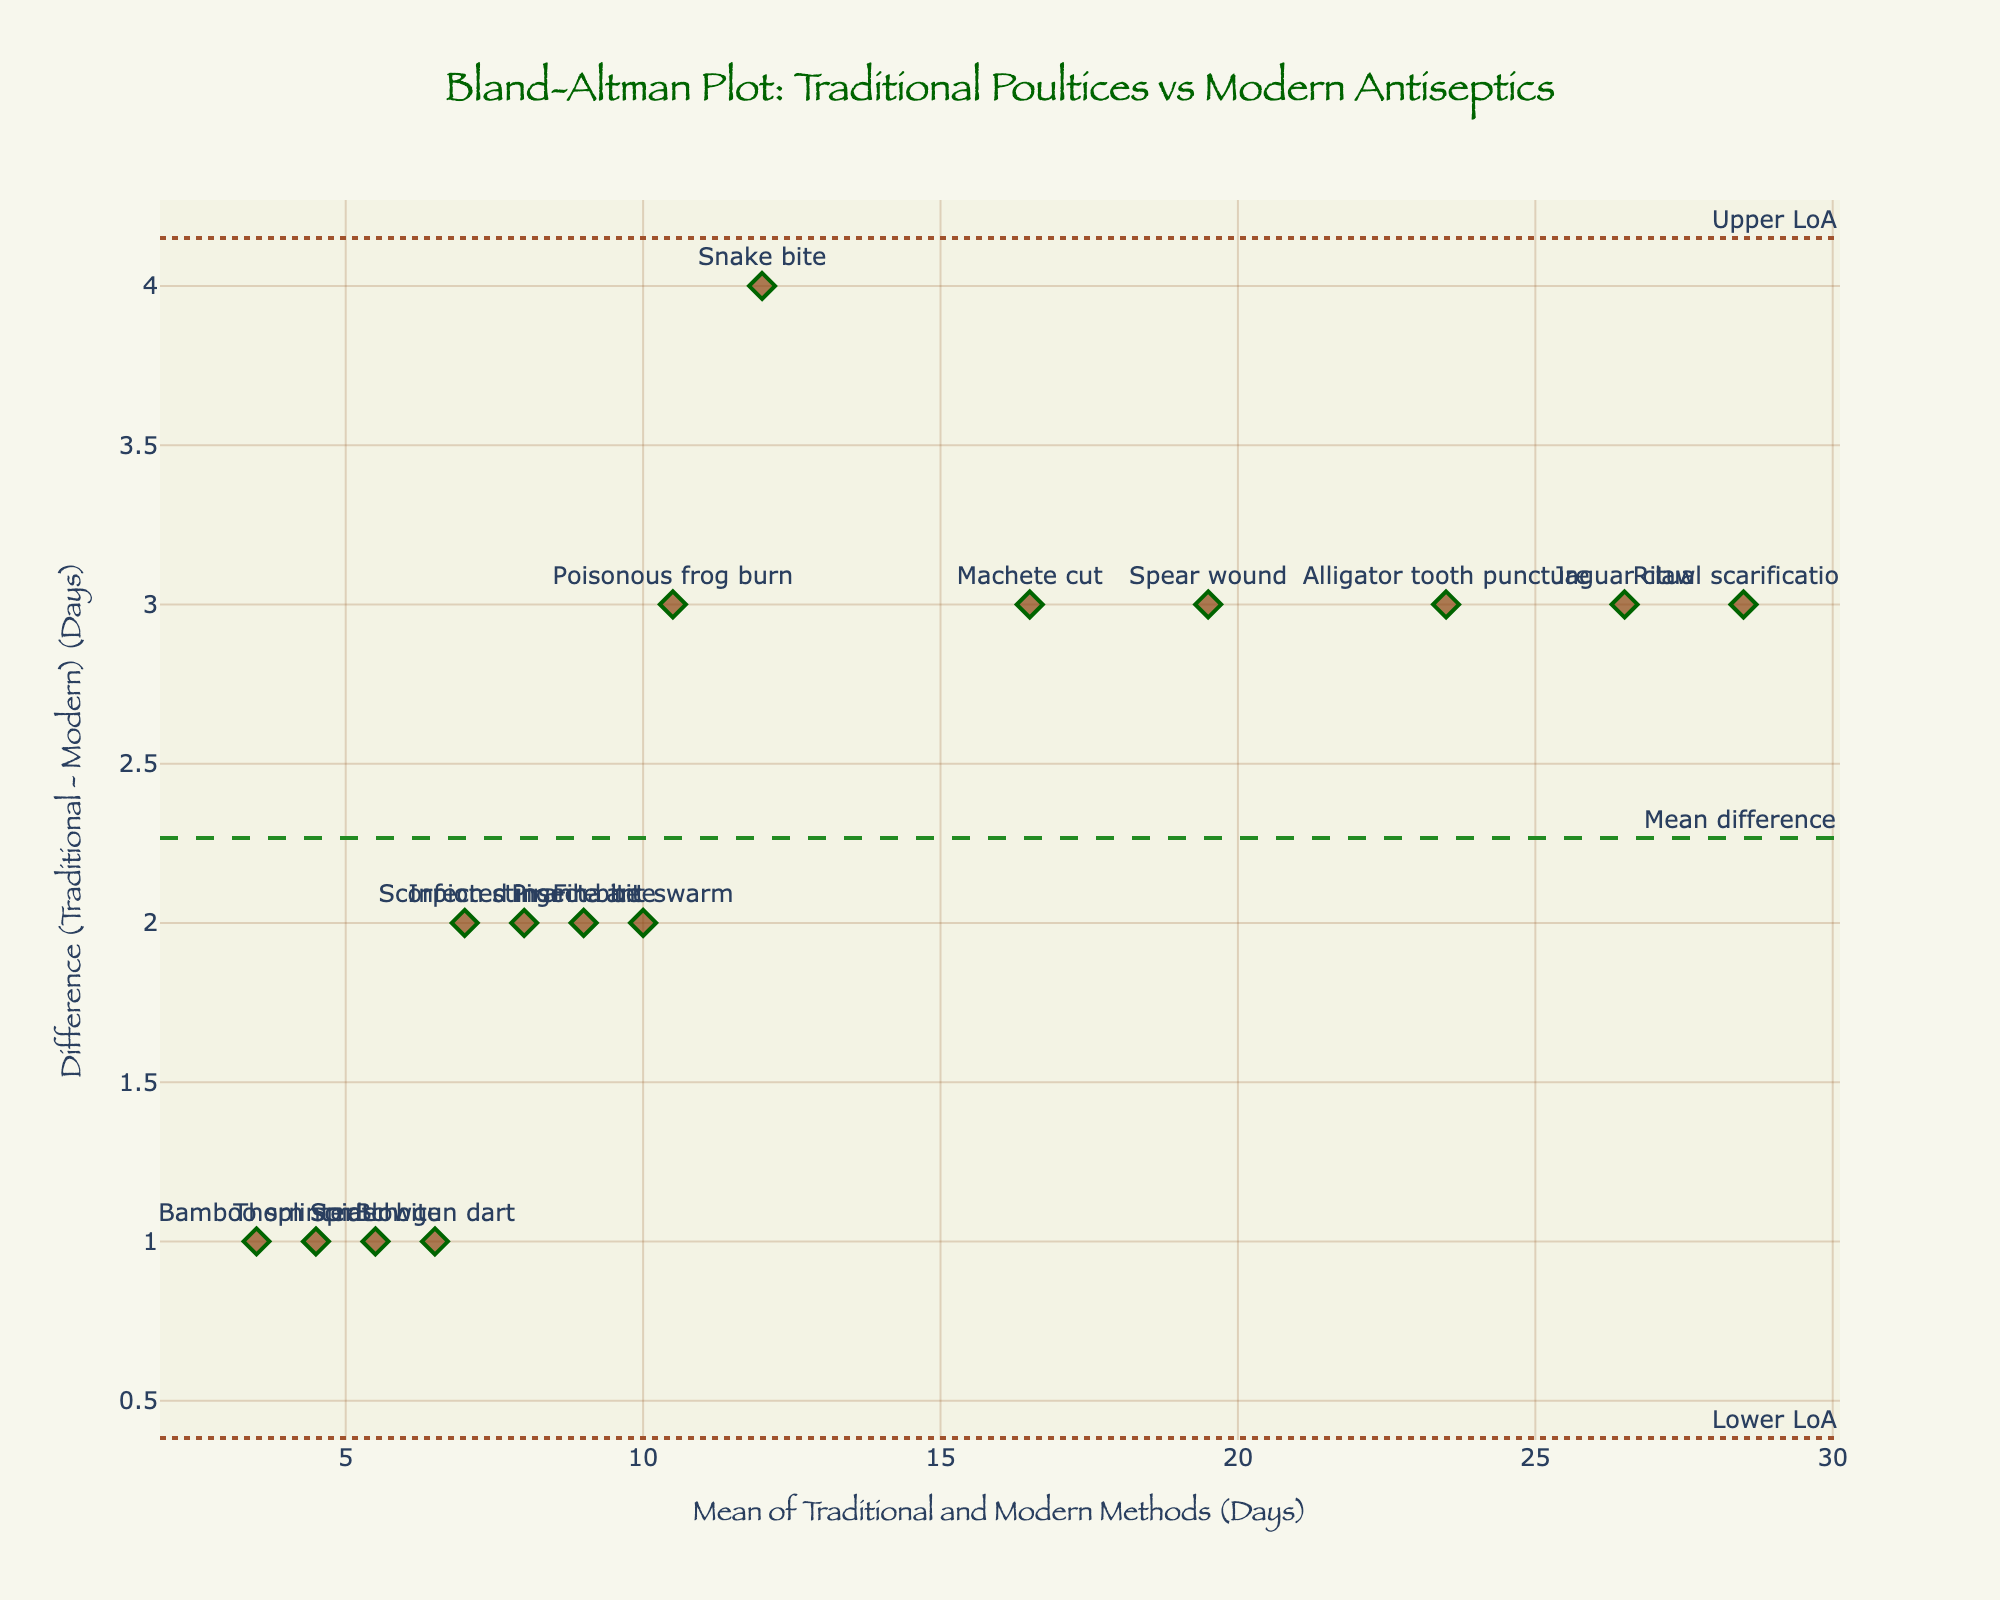What is the title of the plot? The title of the plot is placed at the top-center and can be read directly.
Answer: Bland-Altman Plot: Traditional Poultices vs Modern Antiseptics How many data points are shown in the plot? Each data point represents a wound treatment comparison, plotted as markers. Counting them visually will give the number.
Answer: 15 What does the y-axis represent on this plot? The y-axis label is clearly shown and represents the difference in healing days between traditional and modern methods.
Answer: Difference (Traditional - Modern) (Days) What is the mean difference between the traditional poultices and modern antiseptics? The mean difference is visually represented by a dashed horizontal line labeled "Mean difference" on the plot.
Answer: 2.5 days Which wound has the largest positive difference between traditional and modern healing times? Look for the data point farthest above the zero line on the y-axis and read its label.
Answer: Snake bite What are the limits of agreement (LoA) for this plot? The LoA are represented by the dotted horizontal lines labeled "Upper LoA" and "Lower LoA." Read their values directly.
Answer: Upper LoA: 4.5, Lower LoA: 0.5 Which wound lies closest to the mean difference line? Find the data point nearest to the dashed "Mean difference" line and read its associated label.
Answer: Blowgun dart What is the range of mean healing times observed on the x-axis? The x-axis represents the average number of days for both treatments. Identify the min and max values from the axis ticks.
Answer: 3.5 to 28.5 days Calculate the average mean healing time for wounds treated. Sum all the mean values (average of traditional and modern for each wound) and divide by the number of data points.
Answer: 14.5 days Which wound has the same number of difference days above and below the mean difference? Identify the data points symmetrically placed about the mean difference line compensating equally above and below it.
Answer: Spear wound and Infected insect bite 